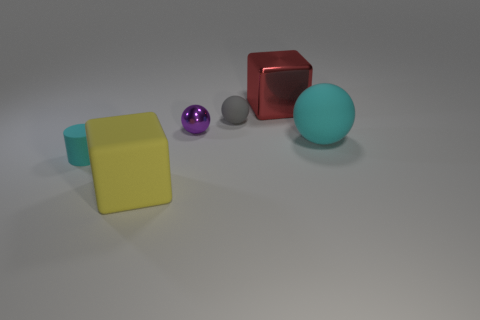Are there fewer gray rubber balls in front of the small cyan object than tiny rubber balls left of the tiny gray rubber thing?
Keep it short and to the point. No. There is a red metallic cube; does it have the same size as the cyan rubber object on the right side of the matte block?
Offer a terse response. Yes. The rubber object that is in front of the big matte ball and behind the yellow matte cube has what shape?
Make the answer very short. Cylinder. What size is the other cyan object that is the same material as the small cyan object?
Provide a short and direct response. Large. How many small cyan rubber cylinders are behind the large cyan object to the right of the tiny purple metal thing?
Provide a short and direct response. 0. Does the cyan thing that is on the right side of the large red cube have the same material as the small gray thing?
Provide a short and direct response. Yes. Are there any other things that are the same material as the tiny gray ball?
Give a very brief answer. Yes. There is a block that is behind the large thing to the left of the small purple shiny sphere; what size is it?
Provide a succinct answer. Large. What size is the cylinder to the left of the large rubber object on the left side of the gray rubber thing on the left side of the big ball?
Keep it short and to the point. Small. There is a cyan rubber object that is in front of the big cyan thing; is its shape the same as the cyan rubber object right of the cyan cylinder?
Ensure brevity in your answer.  No. 